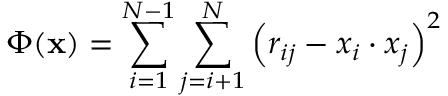Convert formula to latex. <formula><loc_0><loc_0><loc_500><loc_500>\Phi ( x ) = \sum _ { i = 1 } ^ { N - 1 } \sum _ { j = i + 1 } ^ { N } \left ( r _ { i j } - x _ { i } \cdot x _ { j } \right ) ^ { 2 }</formula> 